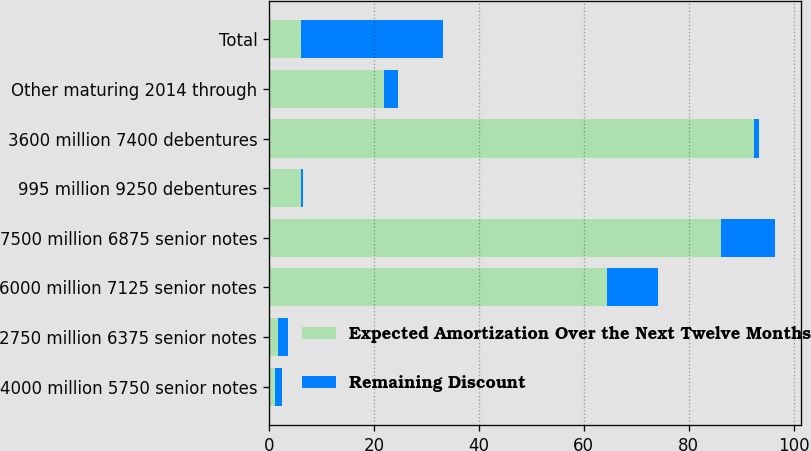Convert chart. <chart><loc_0><loc_0><loc_500><loc_500><stacked_bar_chart><ecel><fcel>4000 million 5750 senior notes<fcel>2750 million 6375 senior notes<fcel>6000 million 7125 senior notes<fcel>7500 million 6875 senior notes<fcel>995 million 9250 debentures<fcel>3600 million 7400 debentures<fcel>Other maturing 2014 through<fcel>Total<nl><fcel>Expected Amortization Over the Next Twelve Months<fcel>1.2<fcel>1.8<fcel>64.5<fcel>86.1<fcel>6.1<fcel>92.4<fcel>21.9<fcel>6.1<nl><fcel>Remaining Discount<fcel>1.2<fcel>1.8<fcel>9.7<fcel>10.4<fcel>0.4<fcel>0.9<fcel>2.6<fcel>27<nl></chart> 